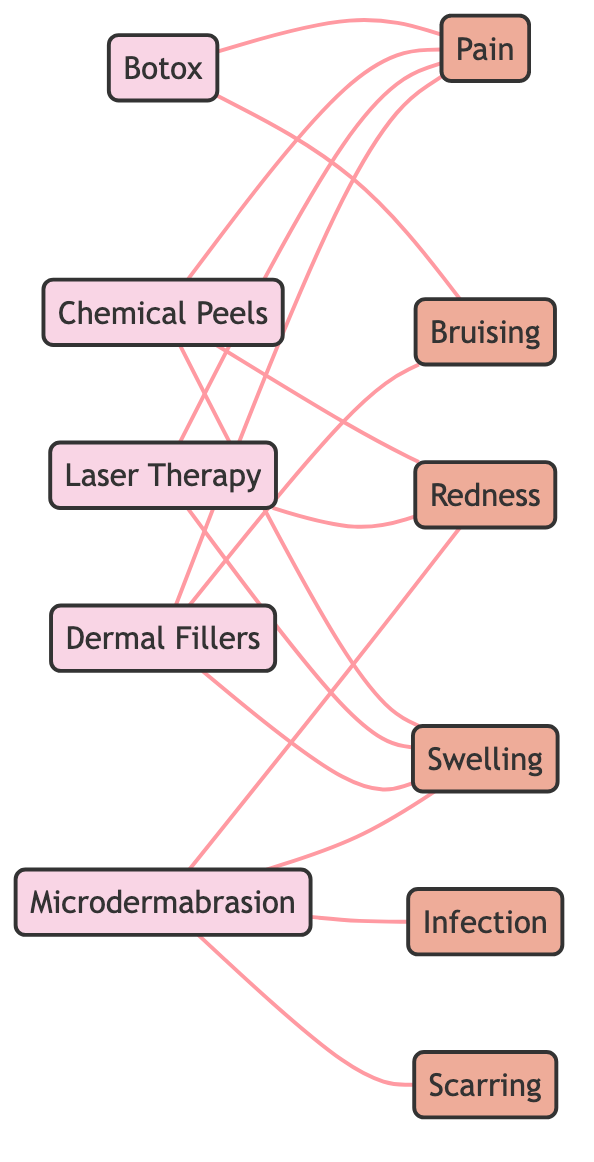What is the total number of treatment modalities? By counting the nodes labeled as treatments (Botox, Chemical Peels, Laser Therapy, Dermal Fillers, Microdermabrasion), we have a total of five treatments listed.
Answer: 5 How many side effects are associated with Microdermabrasion? Looking at the edges connecting Microdermabrasion, we find it is linked to four side effects: Redness, Swelling, Infection, and Scarring. Therefore, the count is four.
Answer: 4 Which treatment modality is connected to Bruising? By examining the connections (edges) from the treatment modalities, we see that both Botox and Dermal Fillers are connected to Bruising. Thus, the answer includes these two treatments.
Answer: Botox, Dermal Fillers What is the node that has the most connections to side effects? Analyzing the edges for each treatment, we find Botox, Chemical Peels, Laser Therapy, and Dermal Fillers all have three connections. However, Microdermabrasion has four connections. Therefore, it has the most connections to side effects among the treatments.
Answer: Microdermabrasion Which side effect is common to both Chemical Peels and Laser Therapy? By checking the edges linked to Chemical Peels and Laser Therapy, we see that both are associated with Swelling, indicating that it is the common side effect between the two modalities.
Answer: Swelling How many total edges are present in the diagram? We can find the total edges by counting each connection in the edges list. There are a total of 13 edges present in the diagram, which represent the relationships between treatments and side effects.
Answer: 13 Is Pain a side effect of all treatment modalities? By reviewing each treatment modality's connections, we can see that Pain is indeed a common side effect for Botox, Chemical Peels, Laser Therapy, and Dermal Fillers, but it is not associated with Microdermabrasion. Therefore, the answer is that it is not a side effect of all modalities.
Answer: No What is the relationship between Laser Therapy and Redness? The diagram shows a direct connection (edge) between Laser Therapy and Redness, indicating a relationship where Laser Therapy can lead to Redness as a side effect.
Answer: Connected 